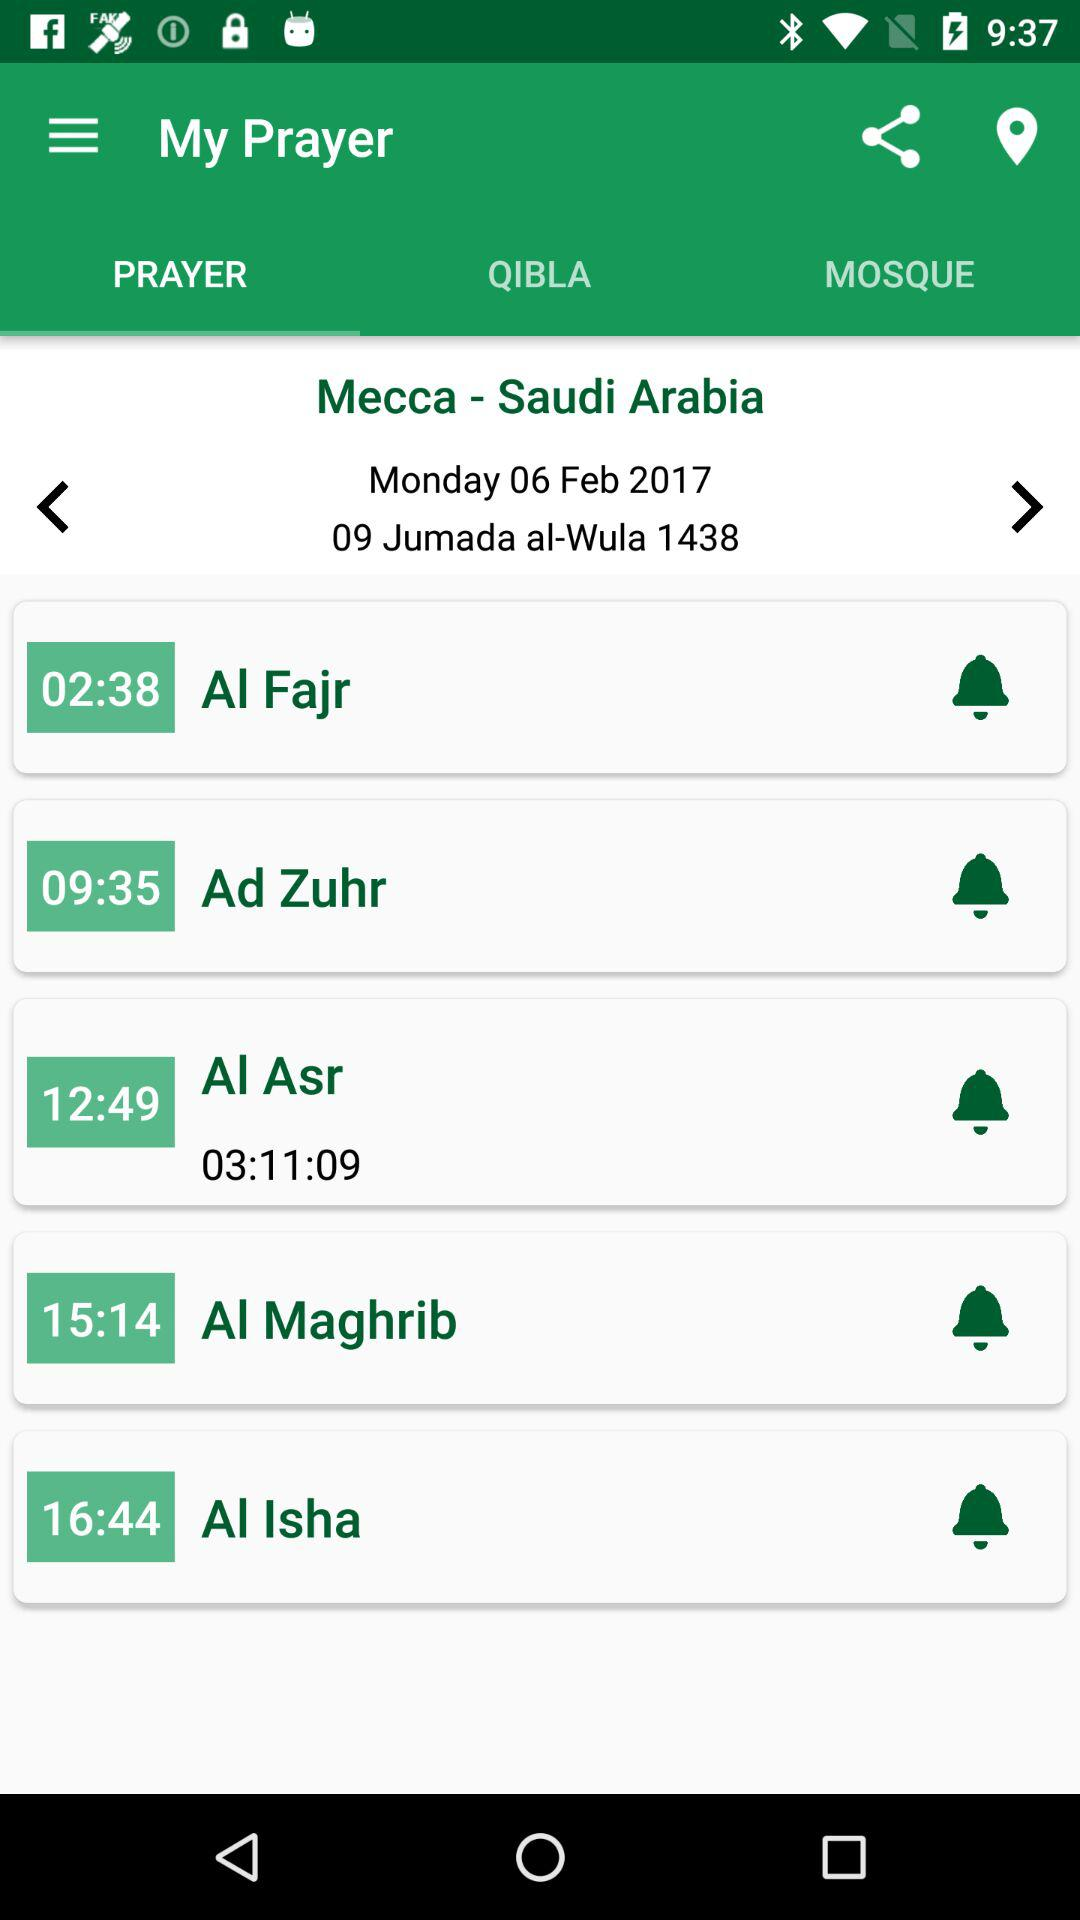Which tab is selected? The selected tab is "PRAYER". 